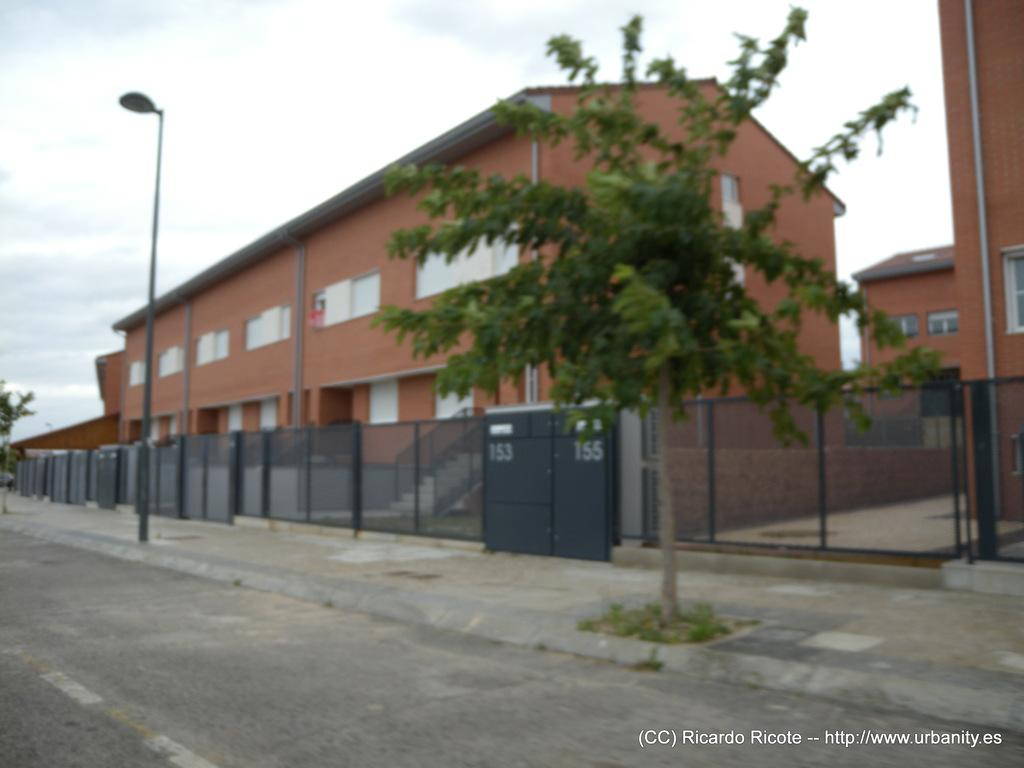What type of path can be seen in the image? There is a footpath in the image. What is located alongside the footpath? There is a road in the image. What type of barrier is present in the image? There is a fence in the image. What type of vegetation is visible in the image? There are trees in the image. What type of structures can be seen in the image? There are buildings with windows in the image. What type of infrastructure is present in the image? There are pipes in the image. What type of lighting fixture is present in the image? There is a street light pole in the image. What can be seen in the background of the image? The sky with clouds is visible in the background of the image. Where are the children playing basketball in the image? There are no children or basketball present in the image. What type of front is visible in the image? The image does not depict a front; it shows a road, footpath, fence, trees, buildings, pipes, street light pole, and sky with clouds. 